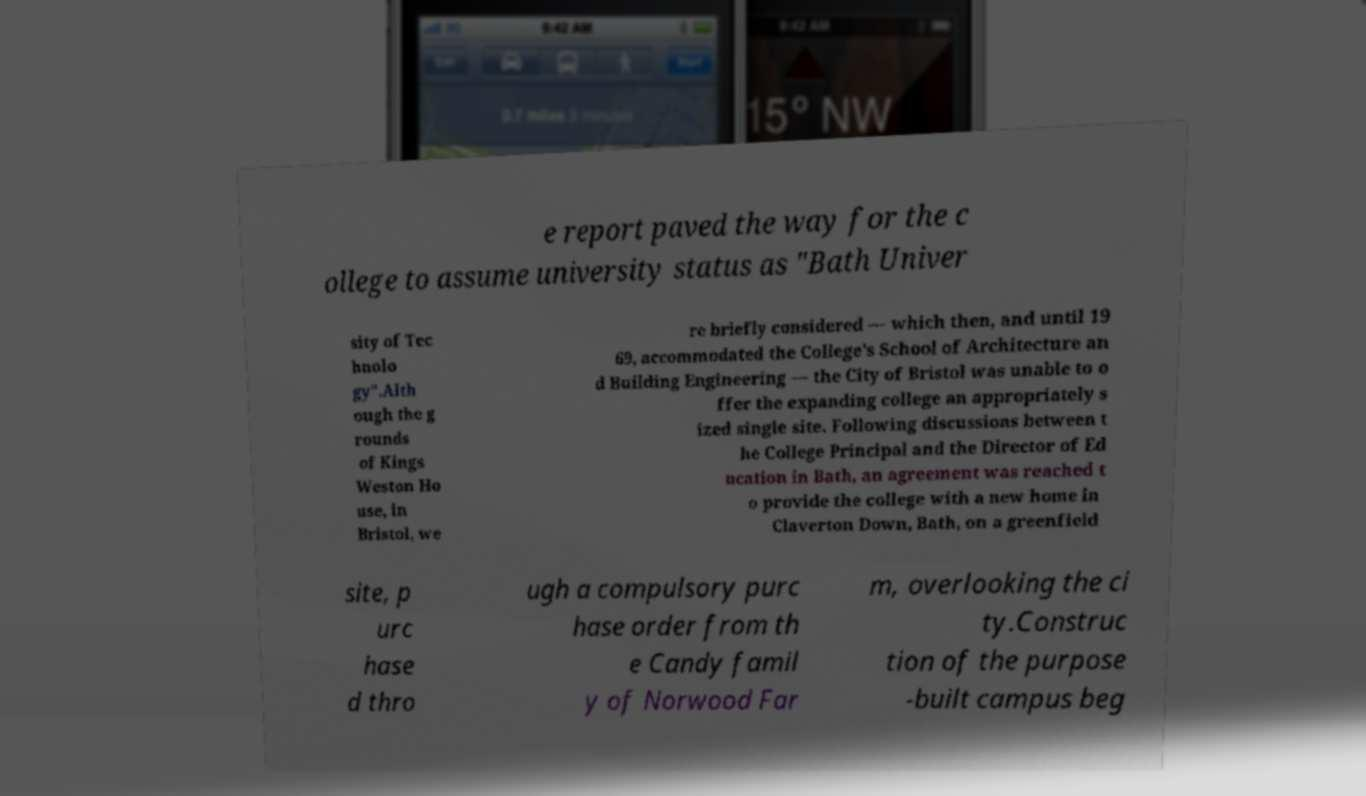For documentation purposes, I need the text within this image transcribed. Could you provide that? e report paved the way for the c ollege to assume university status as "Bath Univer sity of Tec hnolo gy".Alth ough the g rounds of Kings Weston Ho use, in Bristol, we re briefly considered — which then, and until 19 69, accommodated the College's School of Architecture an d Building Engineering — the City of Bristol was unable to o ffer the expanding college an appropriately s ized single site. Following discussions between t he College Principal and the Director of Ed ucation in Bath, an agreement was reached t o provide the college with a new home in Claverton Down, Bath, on a greenfield site, p urc hase d thro ugh a compulsory purc hase order from th e Candy famil y of Norwood Far m, overlooking the ci ty.Construc tion of the purpose -built campus beg 